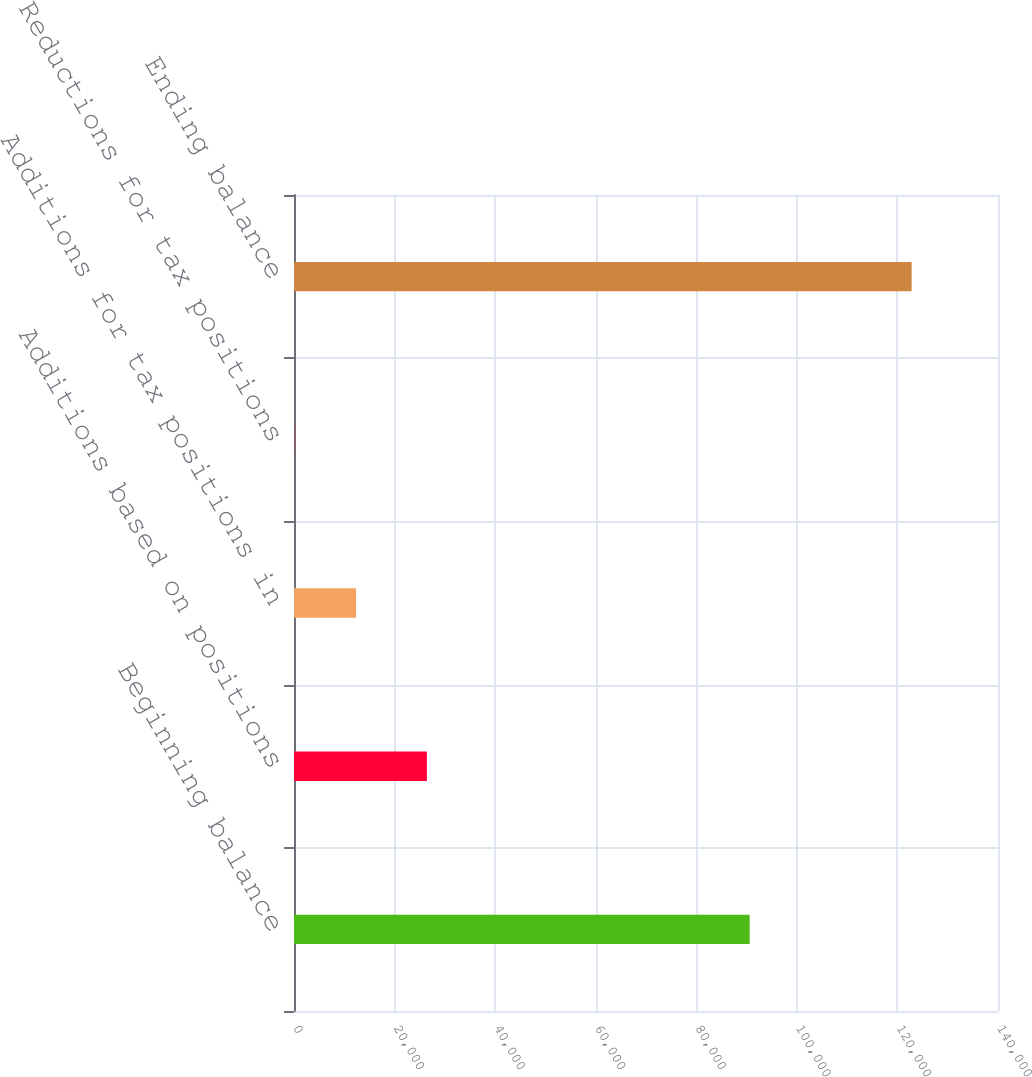Convert chart. <chart><loc_0><loc_0><loc_500><loc_500><bar_chart><fcel>Beginning balance<fcel>Additions based on positions<fcel>Additions for tax positions in<fcel>Reductions for tax positions<fcel>Ending balance<nl><fcel>90615<fcel>26431<fcel>12342.6<fcel>67<fcel>122823<nl></chart> 